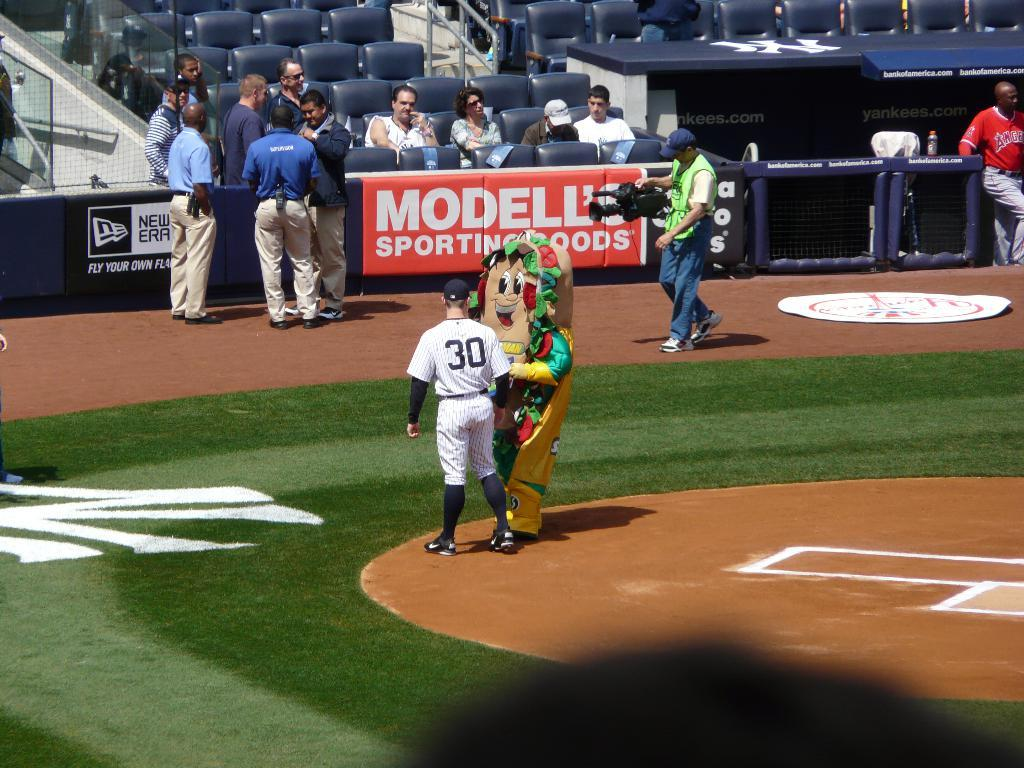<image>
Create a compact narrative representing the image presented. A baseball field that is supported by Modell's sporting goods. 